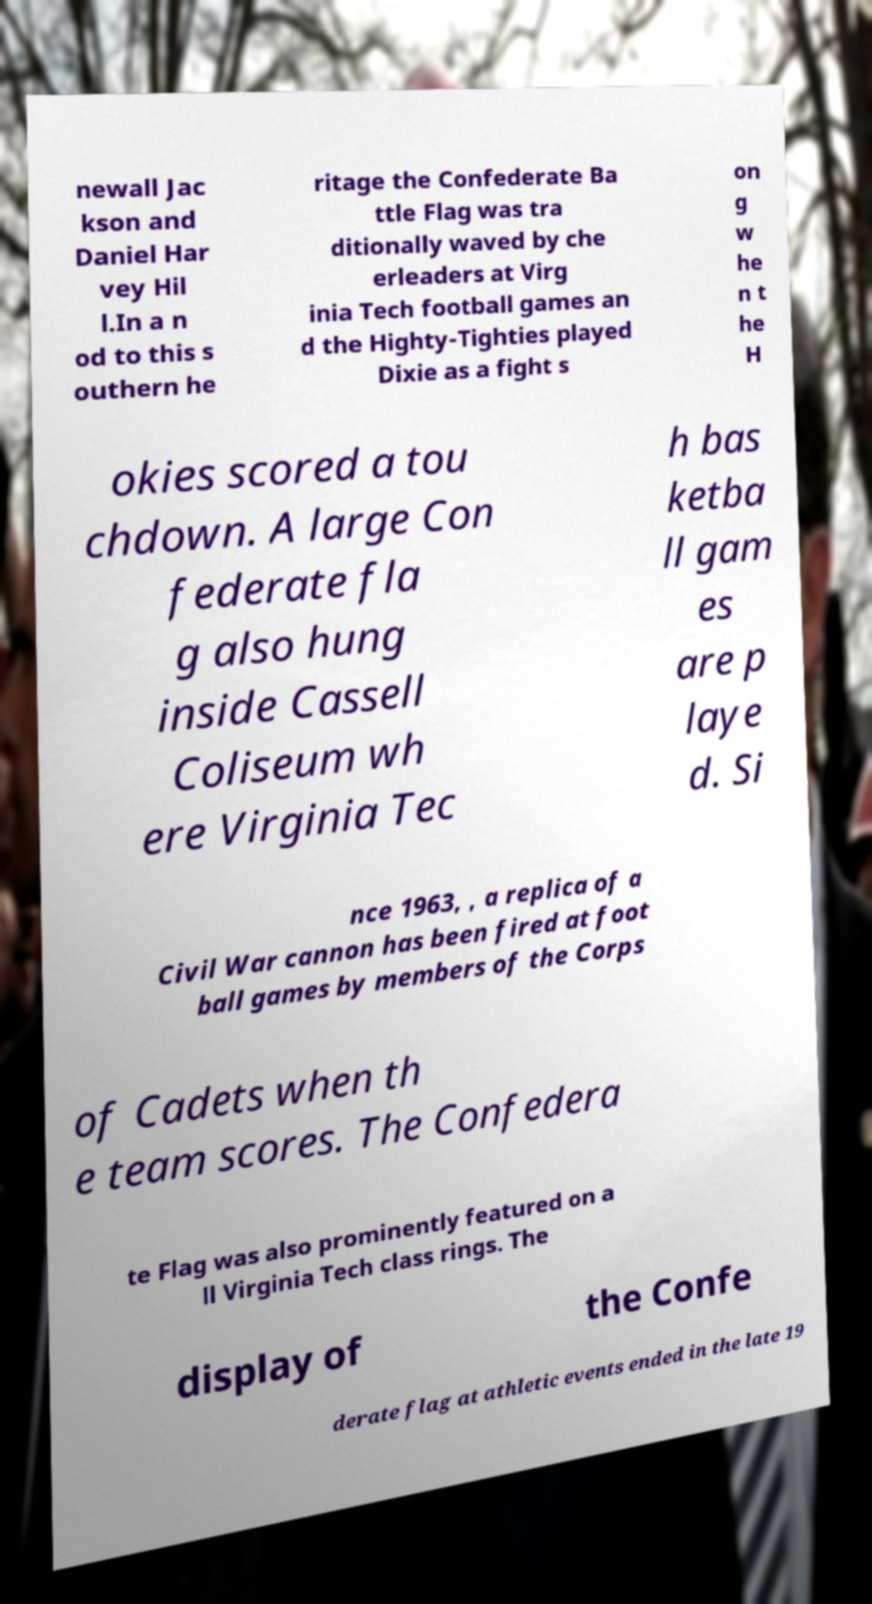I need the written content from this picture converted into text. Can you do that? newall Jac kson and Daniel Har vey Hil l.In a n od to this s outhern he ritage the Confederate Ba ttle Flag was tra ditionally waved by che erleaders at Virg inia Tech football games an d the Highty-Tighties played Dixie as a fight s on g w he n t he H okies scored a tou chdown. A large Con federate fla g also hung inside Cassell Coliseum wh ere Virginia Tec h bas ketba ll gam es are p laye d. Si nce 1963, , a replica of a Civil War cannon has been fired at foot ball games by members of the Corps of Cadets when th e team scores. The Confedera te Flag was also prominently featured on a ll Virginia Tech class rings. The display of the Confe derate flag at athletic events ended in the late 19 